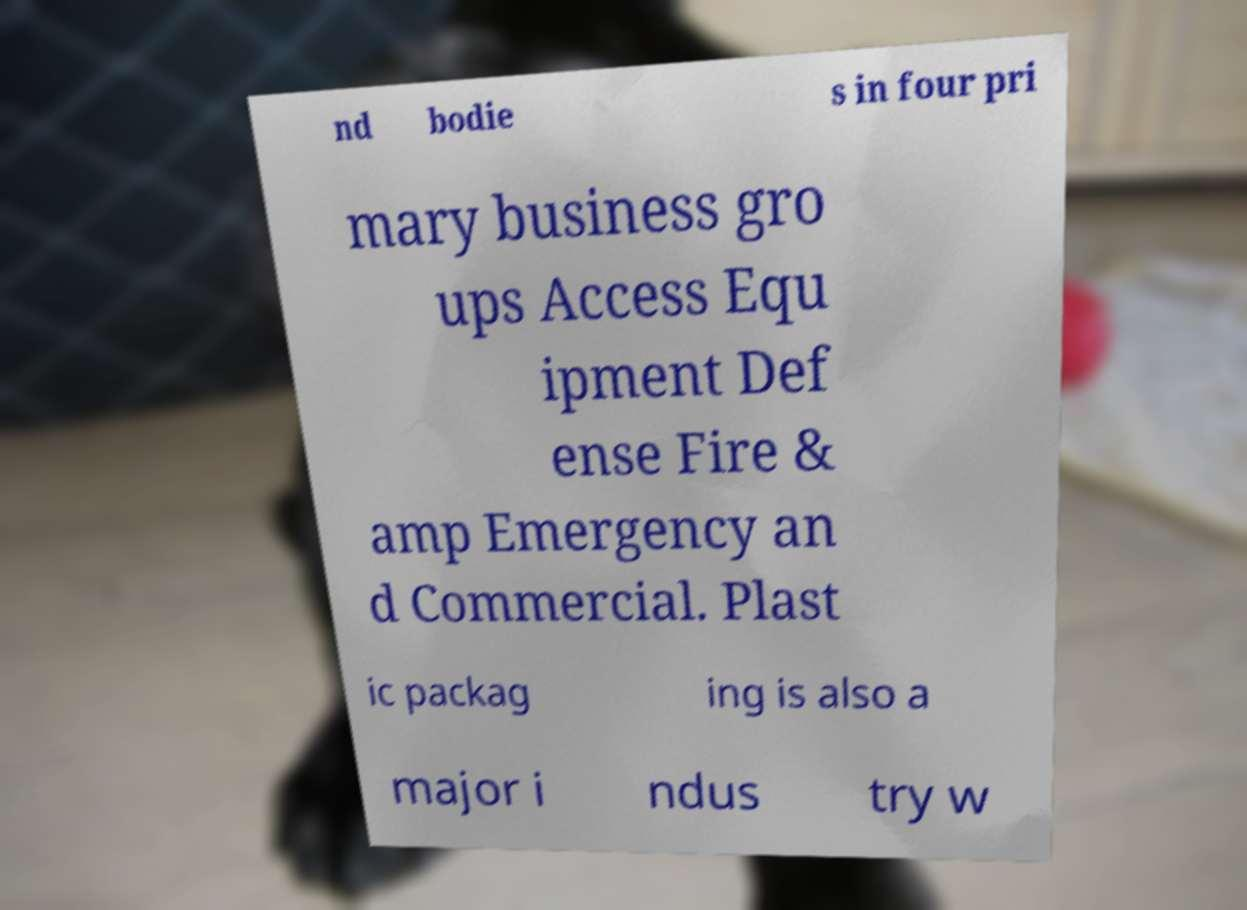Can you read and provide the text displayed in the image?This photo seems to have some interesting text. Can you extract and type it out for me? nd bodie s in four pri mary business gro ups Access Equ ipment Def ense Fire & amp Emergency an d Commercial. Plast ic packag ing is also a major i ndus try w 